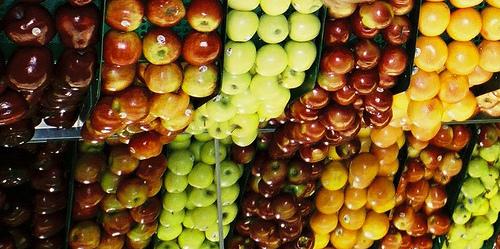How many colors of fruits?
Concise answer only. 4. What types of fruit are in this picture?
Quick response, please. Apples. Can you see any reflections?
Concise answer only. Yes. 